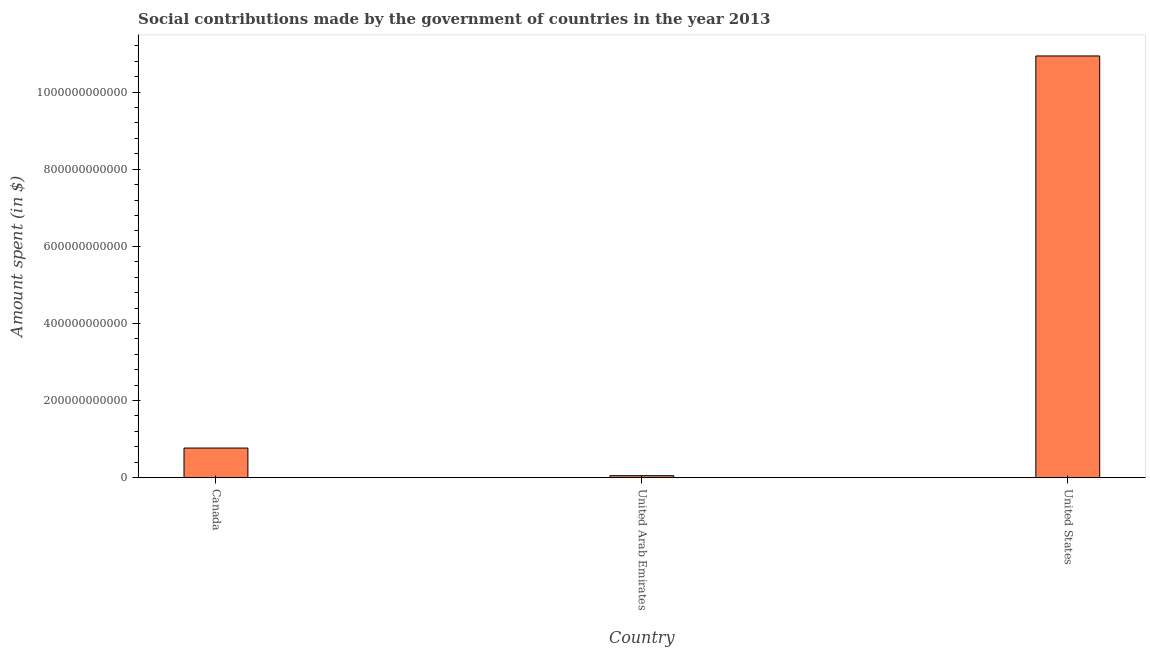Does the graph contain grids?
Provide a short and direct response. No. What is the title of the graph?
Ensure brevity in your answer.  Social contributions made by the government of countries in the year 2013. What is the label or title of the X-axis?
Your response must be concise. Country. What is the label or title of the Y-axis?
Provide a succinct answer. Amount spent (in $). What is the amount spent in making social contributions in United States?
Your response must be concise. 1.09e+12. Across all countries, what is the maximum amount spent in making social contributions?
Your response must be concise. 1.09e+12. Across all countries, what is the minimum amount spent in making social contributions?
Provide a short and direct response. 5.08e+09. In which country was the amount spent in making social contributions maximum?
Your answer should be compact. United States. In which country was the amount spent in making social contributions minimum?
Provide a succinct answer. United Arab Emirates. What is the sum of the amount spent in making social contributions?
Provide a short and direct response. 1.18e+12. What is the difference between the amount spent in making social contributions in Canada and United Arab Emirates?
Give a very brief answer. 7.17e+1. What is the average amount spent in making social contributions per country?
Offer a very short reply. 3.92e+11. What is the median amount spent in making social contributions?
Offer a terse response. 7.68e+1. What is the ratio of the amount spent in making social contributions in Canada to that in United States?
Give a very brief answer. 0.07. Is the difference between the amount spent in making social contributions in Canada and United States greater than the difference between any two countries?
Your response must be concise. No. What is the difference between the highest and the second highest amount spent in making social contributions?
Your answer should be very brief. 1.02e+12. Is the sum of the amount spent in making social contributions in United Arab Emirates and United States greater than the maximum amount spent in making social contributions across all countries?
Offer a terse response. Yes. What is the difference between the highest and the lowest amount spent in making social contributions?
Provide a short and direct response. 1.09e+12. In how many countries, is the amount spent in making social contributions greater than the average amount spent in making social contributions taken over all countries?
Offer a very short reply. 1. Are all the bars in the graph horizontal?
Offer a very short reply. No. How many countries are there in the graph?
Your answer should be very brief. 3. What is the difference between two consecutive major ticks on the Y-axis?
Offer a terse response. 2.00e+11. What is the Amount spent (in $) of Canada?
Provide a succinct answer. 7.68e+1. What is the Amount spent (in $) in United Arab Emirates?
Offer a very short reply. 5.08e+09. What is the Amount spent (in $) in United States?
Provide a succinct answer. 1.09e+12. What is the difference between the Amount spent (in $) in Canada and United Arab Emirates?
Your answer should be very brief. 7.17e+1. What is the difference between the Amount spent (in $) in Canada and United States?
Your answer should be very brief. -1.02e+12. What is the difference between the Amount spent (in $) in United Arab Emirates and United States?
Offer a terse response. -1.09e+12. What is the ratio of the Amount spent (in $) in Canada to that in United Arab Emirates?
Make the answer very short. 15.11. What is the ratio of the Amount spent (in $) in Canada to that in United States?
Ensure brevity in your answer.  0.07. What is the ratio of the Amount spent (in $) in United Arab Emirates to that in United States?
Make the answer very short. 0.01. 